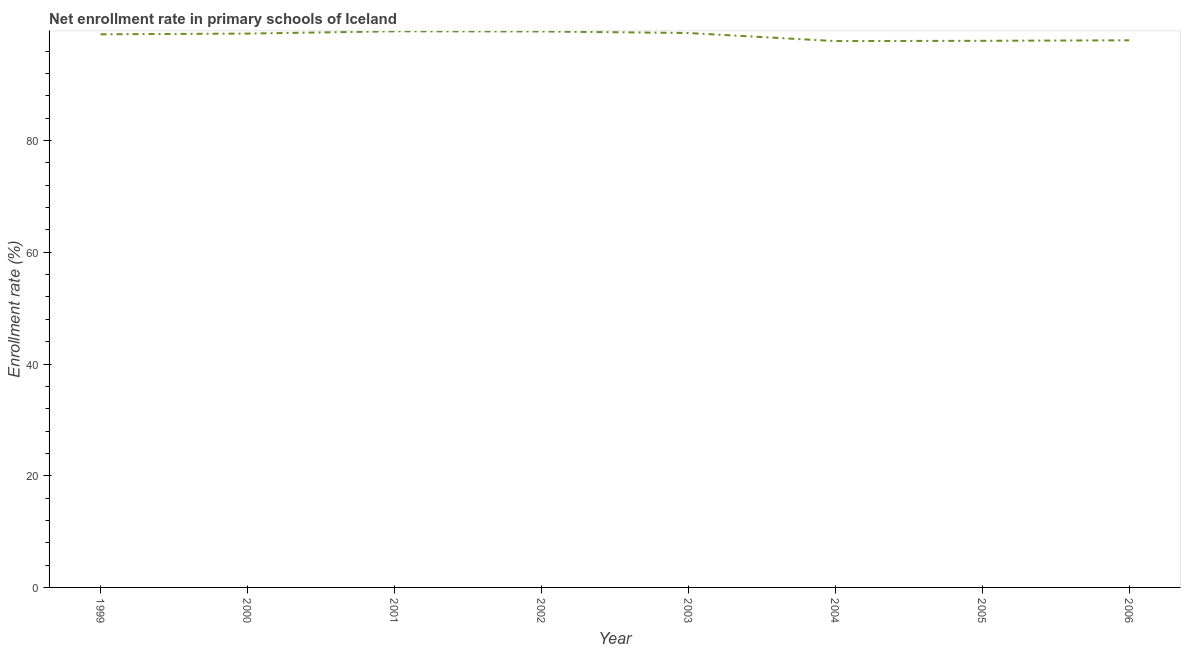What is the net enrollment rate in primary schools in 2006?
Offer a very short reply. 97.96. Across all years, what is the maximum net enrollment rate in primary schools?
Offer a very short reply. 99.57. Across all years, what is the minimum net enrollment rate in primary schools?
Provide a short and direct response. 97.82. What is the sum of the net enrollment rate in primary schools?
Offer a terse response. 790.22. What is the difference between the net enrollment rate in primary schools in 1999 and 2002?
Make the answer very short. -0.51. What is the average net enrollment rate in primary schools per year?
Make the answer very short. 98.78. What is the median net enrollment rate in primary schools?
Offer a very short reply. 99.1. In how many years, is the net enrollment rate in primary schools greater than 68 %?
Provide a short and direct response. 8. Do a majority of the years between 2006 and 2000 (inclusive) have net enrollment rate in primary schools greater than 16 %?
Offer a terse response. Yes. What is the ratio of the net enrollment rate in primary schools in 2000 to that in 2001?
Keep it short and to the point. 1. Is the net enrollment rate in primary schools in 1999 less than that in 2006?
Your answer should be compact. No. What is the difference between the highest and the second highest net enrollment rate in primary schools?
Make the answer very short. 0.03. What is the difference between the highest and the lowest net enrollment rate in primary schools?
Provide a short and direct response. 1.75. How many years are there in the graph?
Offer a very short reply. 8. Does the graph contain any zero values?
Ensure brevity in your answer.  No. What is the title of the graph?
Give a very brief answer. Net enrollment rate in primary schools of Iceland. What is the label or title of the Y-axis?
Ensure brevity in your answer.  Enrollment rate (%). What is the Enrollment rate (%) in 1999?
Keep it short and to the point. 99.03. What is the Enrollment rate (%) of 2000?
Keep it short and to the point. 99.16. What is the Enrollment rate (%) of 2001?
Your answer should be very brief. 99.57. What is the Enrollment rate (%) of 2002?
Offer a terse response. 99.54. What is the Enrollment rate (%) of 2003?
Your answer should be very brief. 99.26. What is the Enrollment rate (%) of 2004?
Offer a terse response. 97.82. What is the Enrollment rate (%) of 2005?
Offer a very short reply. 97.87. What is the Enrollment rate (%) in 2006?
Make the answer very short. 97.96. What is the difference between the Enrollment rate (%) in 1999 and 2000?
Keep it short and to the point. -0.13. What is the difference between the Enrollment rate (%) in 1999 and 2001?
Provide a succinct answer. -0.53. What is the difference between the Enrollment rate (%) in 1999 and 2002?
Provide a short and direct response. -0.51. What is the difference between the Enrollment rate (%) in 1999 and 2003?
Your answer should be very brief. -0.23. What is the difference between the Enrollment rate (%) in 1999 and 2004?
Your response must be concise. 1.21. What is the difference between the Enrollment rate (%) in 1999 and 2005?
Provide a short and direct response. 1.17. What is the difference between the Enrollment rate (%) in 1999 and 2006?
Offer a very short reply. 1.08. What is the difference between the Enrollment rate (%) in 2000 and 2001?
Your answer should be compact. -0.4. What is the difference between the Enrollment rate (%) in 2000 and 2002?
Keep it short and to the point. -0.38. What is the difference between the Enrollment rate (%) in 2000 and 2003?
Give a very brief answer. -0.1. What is the difference between the Enrollment rate (%) in 2000 and 2004?
Your answer should be very brief. 1.34. What is the difference between the Enrollment rate (%) in 2000 and 2005?
Offer a very short reply. 1.3. What is the difference between the Enrollment rate (%) in 2000 and 2006?
Ensure brevity in your answer.  1.21. What is the difference between the Enrollment rate (%) in 2001 and 2002?
Provide a succinct answer. 0.03. What is the difference between the Enrollment rate (%) in 2001 and 2003?
Offer a terse response. 0.3. What is the difference between the Enrollment rate (%) in 2001 and 2004?
Offer a very short reply. 1.75. What is the difference between the Enrollment rate (%) in 2001 and 2005?
Ensure brevity in your answer.  1.7. What is the difference between the Enrollment rate (%) in 2001 and 2006?
Provide a short and direct response. 1.61. What is the difference between the Enrollment rate (%) in 2002 and 2003?
Your response must be concise. 0.28. What is the difference between the Enrollment rate (%) in 2002 and 2004?
Provide a succinct answer. 1.72. What is the difference between the Enrollment rate (%) in 2002 and 2005?
Keep it short and to the point. 1.67. What is the difference between the Enrollment rate (%) in 2002 and 2006?
Provide a short and direct response. 1.58. What is the difference between the Enrollment rate (%) in 2003 and 2004?
Make the answer very short. 1.44. What is the difference between the Enrollment rate (%) in 2003 and 2005?
Your answer should be compact. 1.4. What is the difference between the Enrollment rate (%) in 2003 and 2006?
Ensure brevity in your answer.  1.31. What is the difference between the Enrollment rate (%) in 2004 and 2005?
Your answer should be very brief. -0.05. What is the difference between the Enrollment rate (%) in 2004 and 2006?
Give a very brief answer. -0.14. What is the difference between the Enrollment rate (%) in 2005 and 2006?
Your answer should be compact. -0.09. What is the ratio of the Enrollment rate (%) in 1999 to that in 2001?
Offer a terse response. 0.99. What is the ratio of the Enrollment rate (%) in 1999 to that in 2002?
Your answer should be compact. 0.99. What is the ratio of the Enrollment rate (%) in 1999 to that in 2003?
Make the answer very short. 1. What is the ratio of the Enrollment rate (%) in 1999 to that in 2005?
Give a very brief answer. 1.01. What is the ratio of the Enrollment rate (%) in 2000 to that in 2004?
Your answer should be very brief. 1.01. What is the ratio of the Enrollment rate (%) in 2000 to that in 2006?
Give a very brief answer. 1.01. What is the ratio of the Enrollment rate (%) in 2001 to that in 2002?
Offer a terse response. 1. What is the ratio of the Enrollment rate (%) in 2001 to that in 2003?
Your answer should be very brief. 1. What is the ratio of the Enrollment rate (%) in 2001 to that in 2005?
Keep it short and to the point. 1.02. What is the ratio of the Enrollment rate (%) in 2002 to that in 2003?
Make the answer very short. 1. What is the ratio of the Enrollment rate (%) in 2002 to that in 2004?
Your answer should be very brief. 1.02. What is the ratio of the Enrollment rate (%) in 2003 to that in 2005?
Give a very brief answer. 1.01. What is the ratio of the Enrollment rate (%) in 2003 to that in 2006?
Provide a short and direct response. 1.01. What is the ratio of the Enrollment rate (%) in 2005 to that in 2006?
Offer a very short reply. 1. 